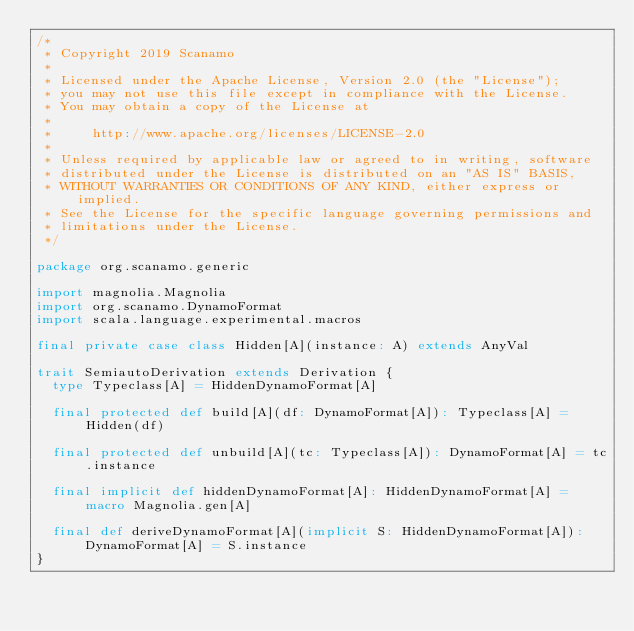<code> <loc_0><loc_0><loc_500><loc_500><_Scala_>/*
 * Copyright 2019 Scanamo
 *
 * Licensed under the Apache License, Version 2.0 (the "License");
 * you may not use this file except in compliance with the License.
 * You may obtain a copy of the License at
 *
 *     http://www.apache.org/licenses/LICENSE-2.0
 *
 * Unless required by applicable law or agreed to in writing, software
 * distributed under the License is distributed on an "AS IS" BASIS,
 * WITHOUT WARRANTIES OR CONDITIONS OF ANY KIND, either express or implied.
 * See the License for the specific language governing permissions and
 * limitations under the License.
 */

package org.scanamo.generic

import magnolia.Magnolia
import org.scanamo.DynamoFormat
import scala.language.experimental.macros

final private case class Hidden[A](instance: A) extends AnyVal

trait SemiautoDerivation extends Derivation {
  type Typeclass[A] = HiddenDynamoFormat[A]

  final protected def build[A](df: DynamoFormat[A]): Typeclass[A] = Hidden(df)

  final protected def unbuild[A](tc: Typeclass[A]): DynamoFormat[A] = tc.instance

  final implicit def hiddenDynamoFormat[A]: HiddenDynamoFormat[A] = macro Magnolia.gen[A]

  final def deriveDynamoFormat[A](implicit S: HiddenDynamoFormat[A]): DynamoFormat[A] = S.instance
}
</code> 